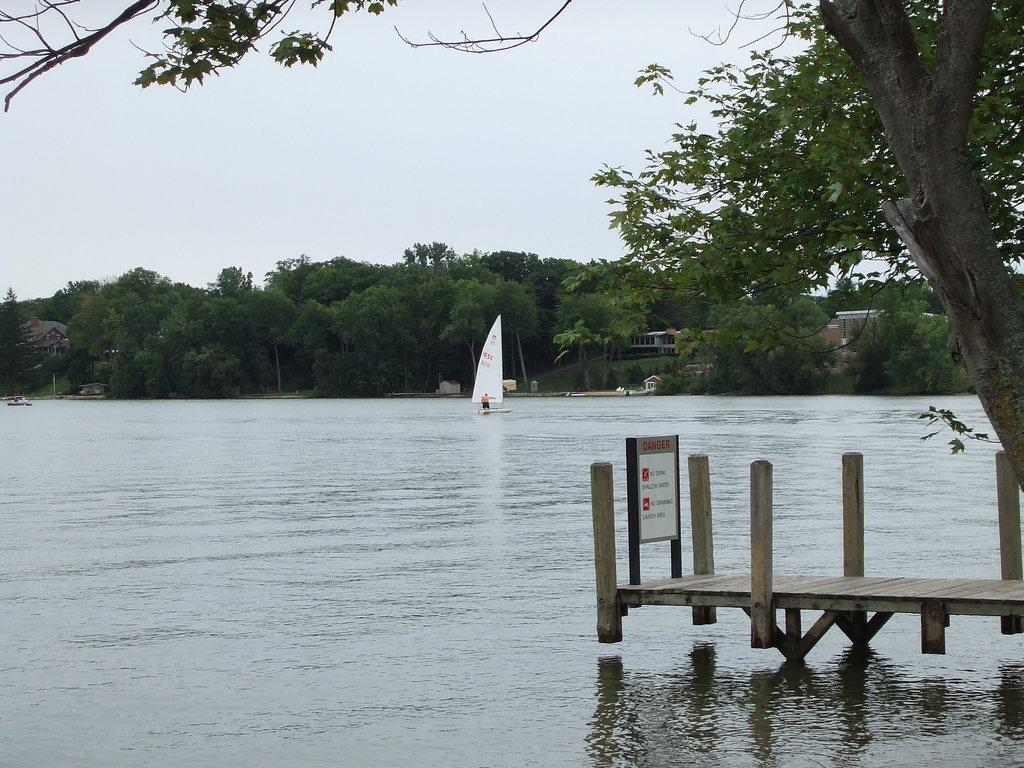How many boats can be seen in the image? There are two boats in the image. What is the location of the boats in the image? The boats are on water in the image. What can be seen in the background of the image? There are trees and buildings in the background of the image. What type of transport does the manager use to travel to the office in the image? There is no manager or office present in the image, and therefore no such transport can be observed. Can you see a plane in the image? No, there is no plane visible in the image. 